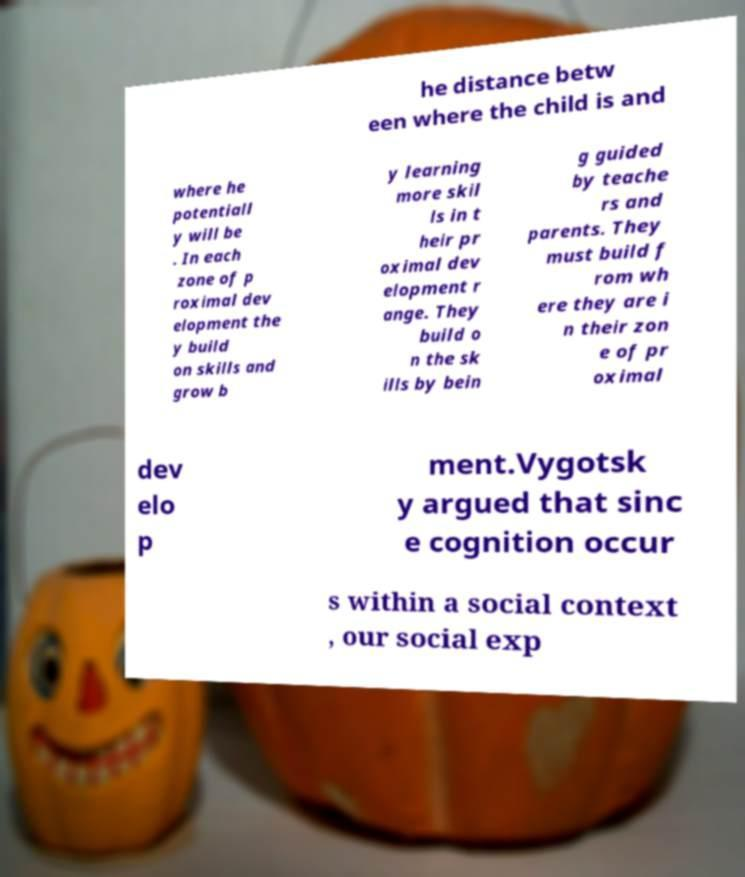Can you accurately transcribe the text from the provided image for me? he distance betw een where the child is and where he potentiall y will be . In each zone of p roximal dev elopment the y build on skills and grow b y learning more skil ls in t heir pr oximal dev elopment r ange. They build o n the sk ills by bein g guided by teache rs and parents. They must build f rom wh ere they are i n their zon e of pr oximal dev elo p ment.Vygotsk y argued that sinc e cognition occur s within a social context , our social exp 